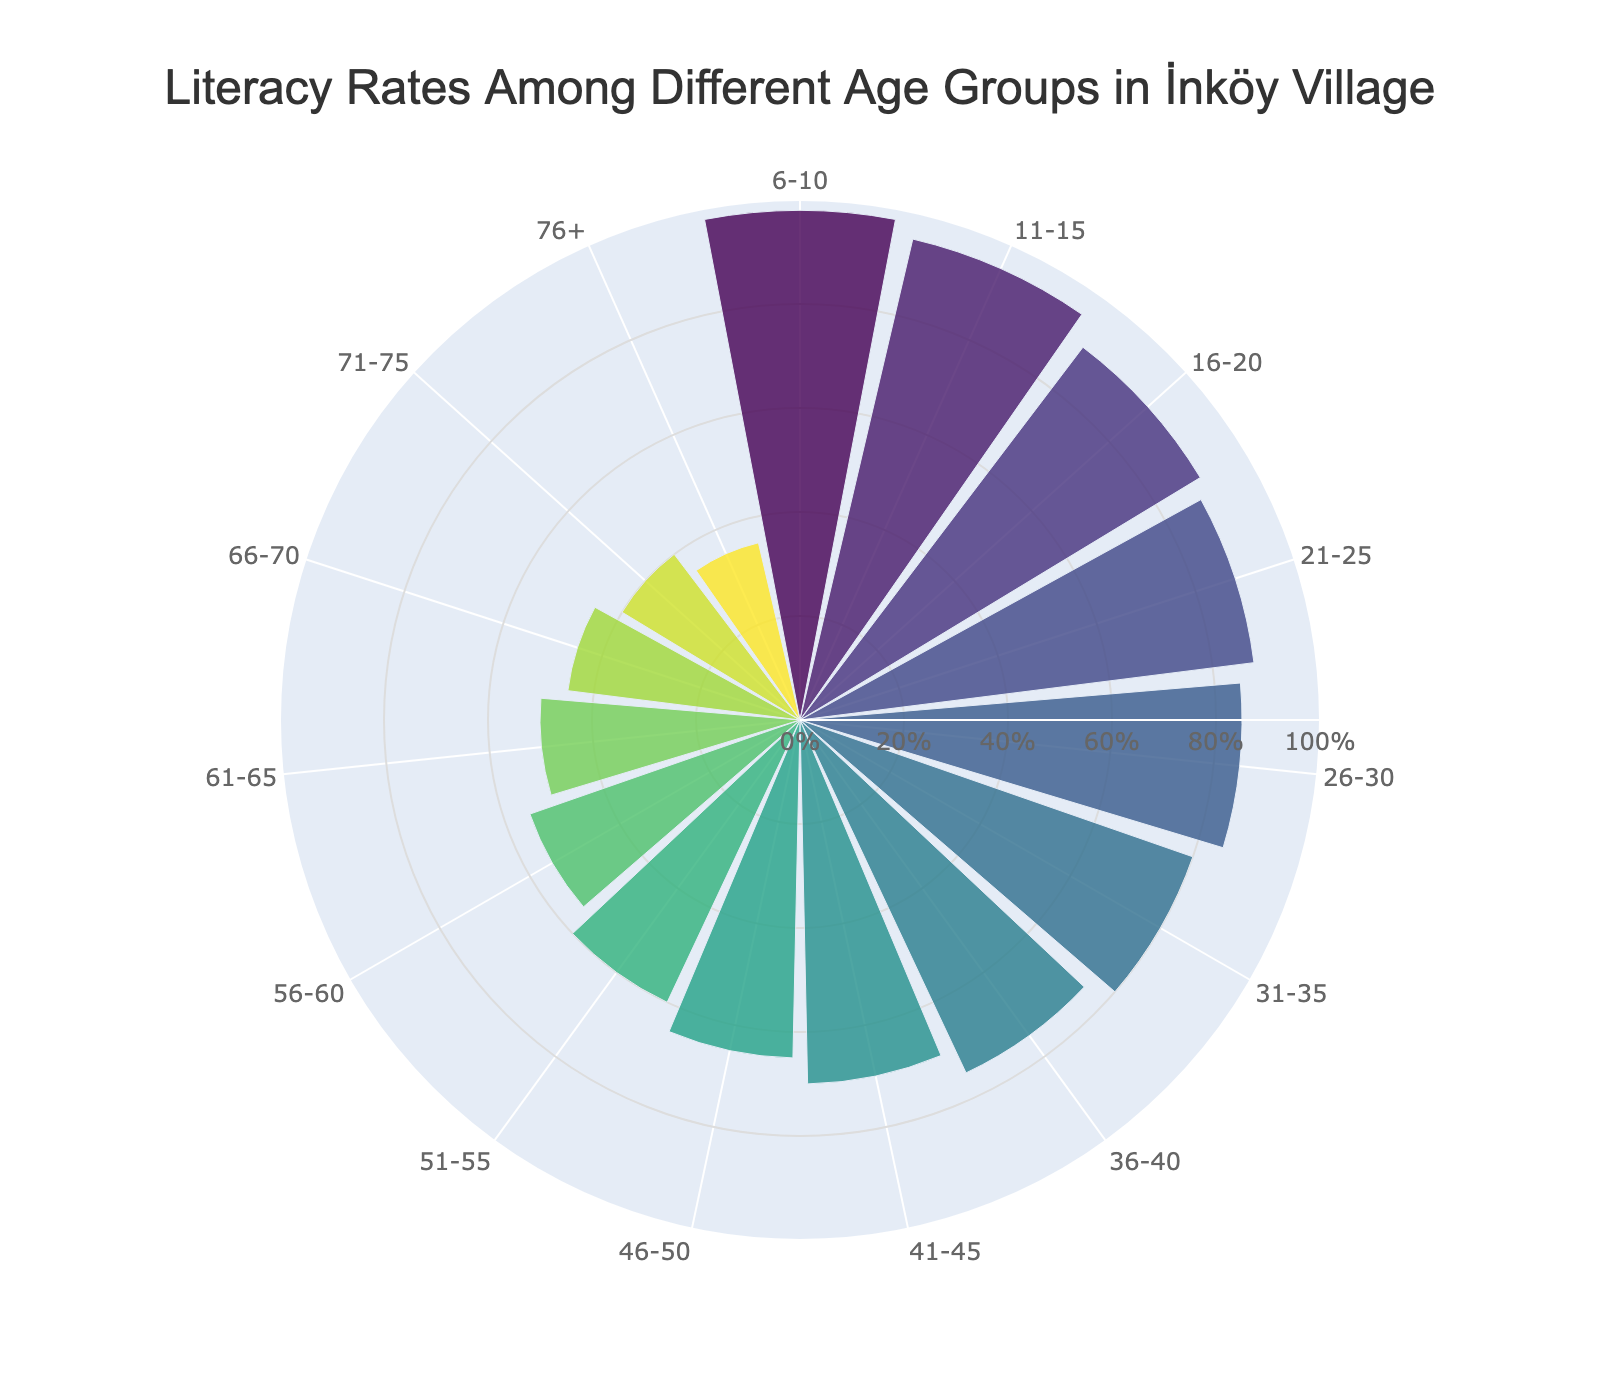What is the title of the chart? The title is always prominently displayed at the top of the chart to give an overview of the information being presented. Here, the title is: "Literacy Rates Among Different Age Groups in İnköy Village".
Answer: Literacy Rates Among Different Age Groups in İnköy Village What is the color scheme used in the rose chart? The chart utilizes a color gradient to represent different age groups, ranging from lighter to darker shades. Specifically, it uses the 'Viridis' colorscale which transitions from yellowish-green to darker blueish tones.
Answer: Viridis colorscale What is the age group with the highest literacy rate? To answer this, look for the bar with the maximum radius (indicating the highest literacy rate). The corresponding age group is labeled at the angle where this bar ends. Here, the highest point is for the age group 6-10, which has a literacy rate of 98%.
Answer: 6-10 What is the difference in literacy rates between the age groups 21-25 and 51-55? From the chart, identify the literacy rates for both age groups (88% for 21-25 and 60% for 51-55). Subtract the smaller literacy rate from the larger one: 88% - 60% = 28%.
Answer: 28% Which two consecutive age groups have the largest drop in literacy rates? Compare the differences between consecutive age groups. The largest drop observed is between 26-30 (85%) and 31-35 (80%). The difference is 85% - 80% = 5%.
Answer: 26-30 and 31-35 What is the average literacy rate of all the displayed age groups? To compute the average, add all the literacy rates and divide by the total number of age groups. The rates are: 98, 95, 90, 88, 85, 80, 75, 70, 65, 60, 55, 50, 45, 40, and 35. The sum is 1026, and the number of age groups is 15. So, the average is 1026 / 15 = 68.4%.
Answer: 68.4% How does the literacy rate change as the age groups get older? Observe the pattern in the chart. It consistently shows that the literacy rate decreases as the age groups progress from younger to older.
Answer: Decreases Which age group has the closest literacy rate to the average literacy rate of all age groups? The average literacy rate is 68.4%. Compare this to the rates in each age group. The age group 41-45 has a rate of 70%, which is the closest to 68.4%.
Answer: 41-45 What is the literacy rate of the oldest age group displayed in the chart? Locate the angle representing the oldest age group (76+). From the chart, it shows a literacy rate of 35%.
Answer: 35% Which age group has a literacy rate closest to 50%? Identify the bar closest to the 50% radial mark. The age group 61-65 has a literacy rate of 50%.
Answer: 61-65 